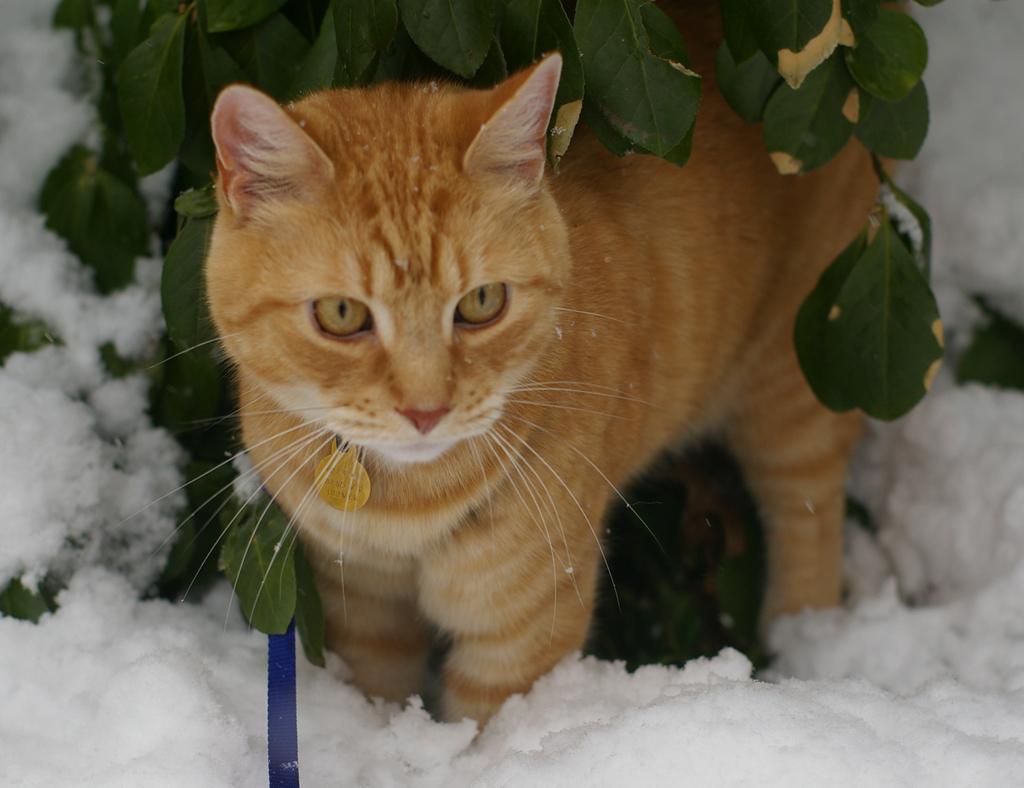Could you give a brief overview of what you see in this image? In the image on the ground there is a snow. In the middle of the snow there is a brown color cat standing. Above the cat there are leaves. 